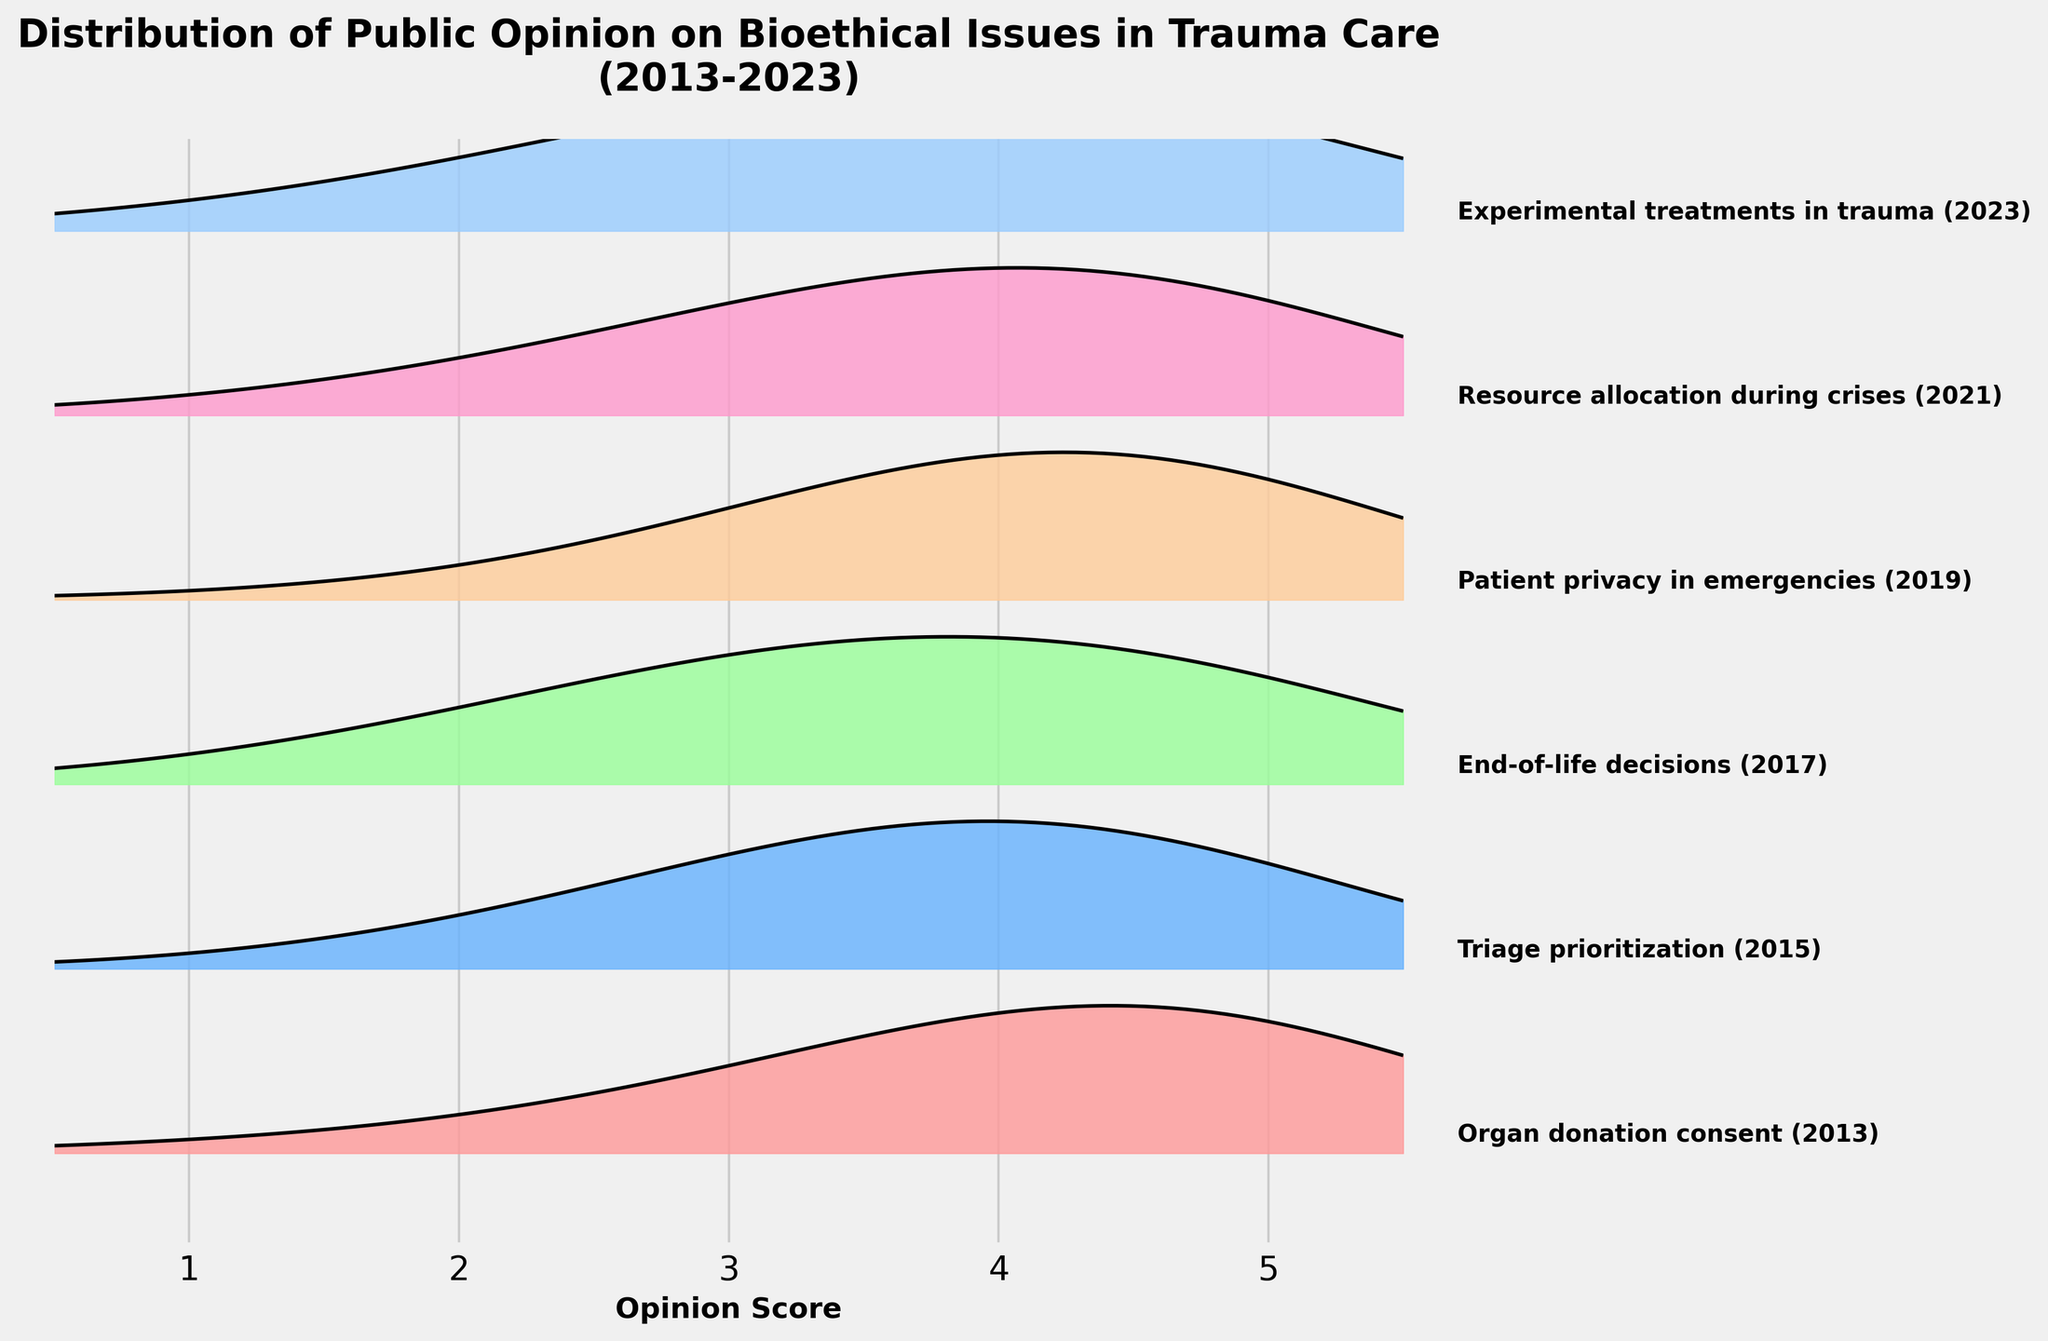How many bioethical issues are tracked in the figure? There are labels next to each ridgeline indicating the different bioethical issues. Counting these labels, we observe six different issues.
Answer: 6 Which bioethical issue had the highest peak density in 2013? The issue "Organ donation consent" in 2013 has a clearly visible high peak density as shown by the width and height of the ridgeline plot.
Answer: Organ donation consent What is the range of the opinion scores on the x-axis? Observing the x-axis, the scores range from 1 to 5. This is visible from the axis ticks.
Answer: 1 to 5 How did the public opinion score distribution for "End-of-life decisions" peak in 2017 compare to the distribution of "Resource allocation during crises" in 2021? The density peak for "End-of-life decisions" in 2017 is highest around score 4, while "Resource allocation during crises" in 2021 also peaked around score 4 with slightly different density values. Both show a similar amount of density concentration around score 4.
Answer: Similar at score 4 In which year was the distribution for "Triage prioritization" reported? The text adjacent to the ridgeline for "Triage prioritization" shows the year 2015.
Answer: 2015 What's the overall trend of peak opinion scores over the years observed? The figure shows peak opinion scores mostly concentrate around scores 4 and 5, indicating a general public inclination towards higher agreement over time for the tracked issues.
Answer: High agreement How does the public opinion density for "Experimental treatments in trauma" in 2023 differ from "Patient privacy in emergencies" in 2019? Comparing the ridgelines, "Experimental treatments in trauma" in 2023 shows a peak around a score 4, but also a higher density at the lower scores, while "Patient privacy in emergencies" in 2019 has a sharper peak around score 4 and overall higher densities at middle scores 3 and 4.
Answer: Different density distributions Which bioethical issue in the given period has the most diverse opinion scores? "Experimental treatments in trauma" in 2023 shows a broader spread of opinion scores as compared to other issues, evidenced by higher density across a wider range of scores from 1 to 5.
Answer: Experimental treatments in trauma Did any issue have a density peak exactly at score 1? Observing the figure, no ridgeline shows a peak precisely at score 1; most peaks are around scores 3 and above.
Answer: No Which bioethical issue showed a distinct plateau instead of a sharp peak in density? "Triage prioritization" in 2015 had a flatter distribution, indicating a plateau rather than a sharp peak. This can be seen from the ridgeline's wider base at the peak density.
Answer: Triage prioritization 